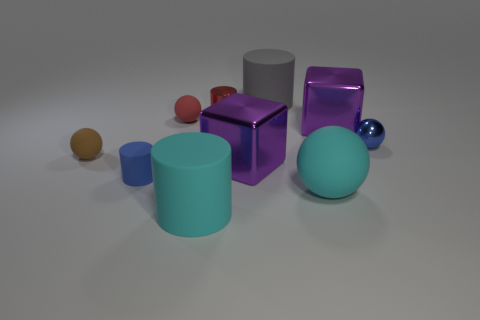Subtract all blue cylinders. How many cylinders are left? 3 Subtract all red spheres. How many spheres are left? 3 Subtract 1 spheres. How many spheres are left? 3 Subtract all cubes. How many objects are left? 8 Subtract all green balls. Subtract all blue cylinders. How many balls are left? 4 Subtract all tiny red matte balls. Subtract all large cyan matte cylinders. How many objects are left? 8 Add 4 red balls. How many red balls are left? 5 Add 4 tiny blue metal things. How many tiny blue metal things exist? 5 Subtract 0 brown cylinders. How many objects are left? 10 